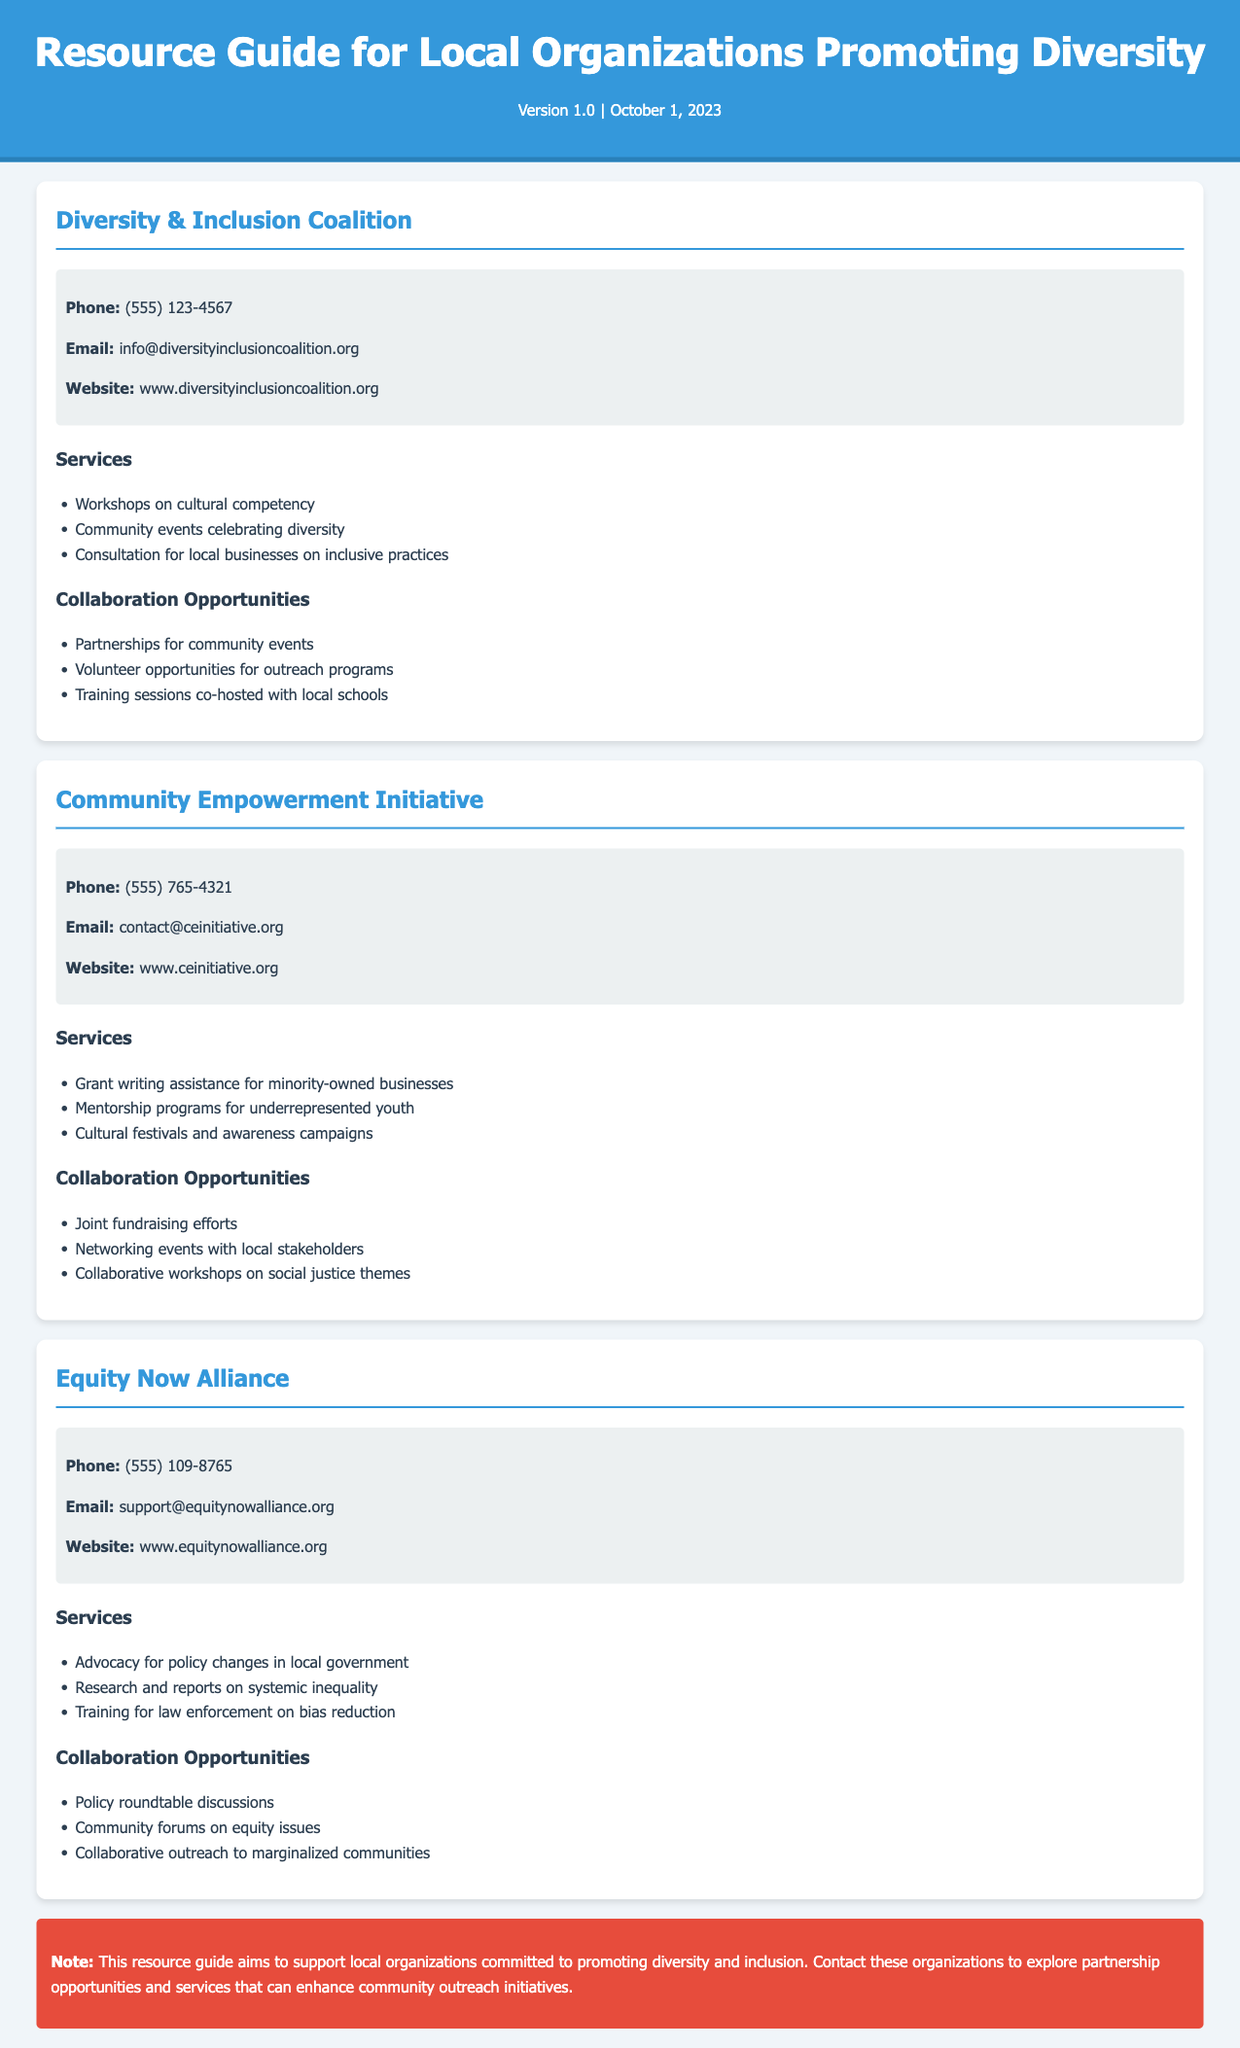what is the name of the first organization listed? The first organization listed in the document is in the title of its card.
Answer: Diversity & Inclusion Coalition what is the phone number for the Community Empowerment Initiative? The phone number is specified in the contact information section of its card.
Answer: (555) 765-4321 how many services does the Equity Now Alliance offer? The number of services is counted from the list provided under the services section.
Answer: 3 what is one collaboration opportunity offered by the Diversity & Inclusion Coalition? One collaboration opportunity is mentioned in the collaboration section of its card.
Answer: Partnerships for community events what is the website of the Equity Now Alliance? The website is listed in the contact information under the organization’s details.
Answer: www.equitynowalliance.org how many organizations are listed in the document? The total number of organizations is determined by counting each org-card in the document.
Answer: 3 what is one service provided by the Community Empowerment Initiative? One service is mentioned in the services section of its card.
Answer: Grant writing assistance for minority-owned businesses which organization offers training for law enforcement on bias reduction? The service is detailed under the Equity Now Alliance's services section.
Answer: Equity Now Alliance what is the note in the document regarding the resource guide? The note summarizes the purpose of the resource guide as stated at the end of the document.
Answer: This resource guide aims to support local organizations committed to promoting diversity and inclusion 